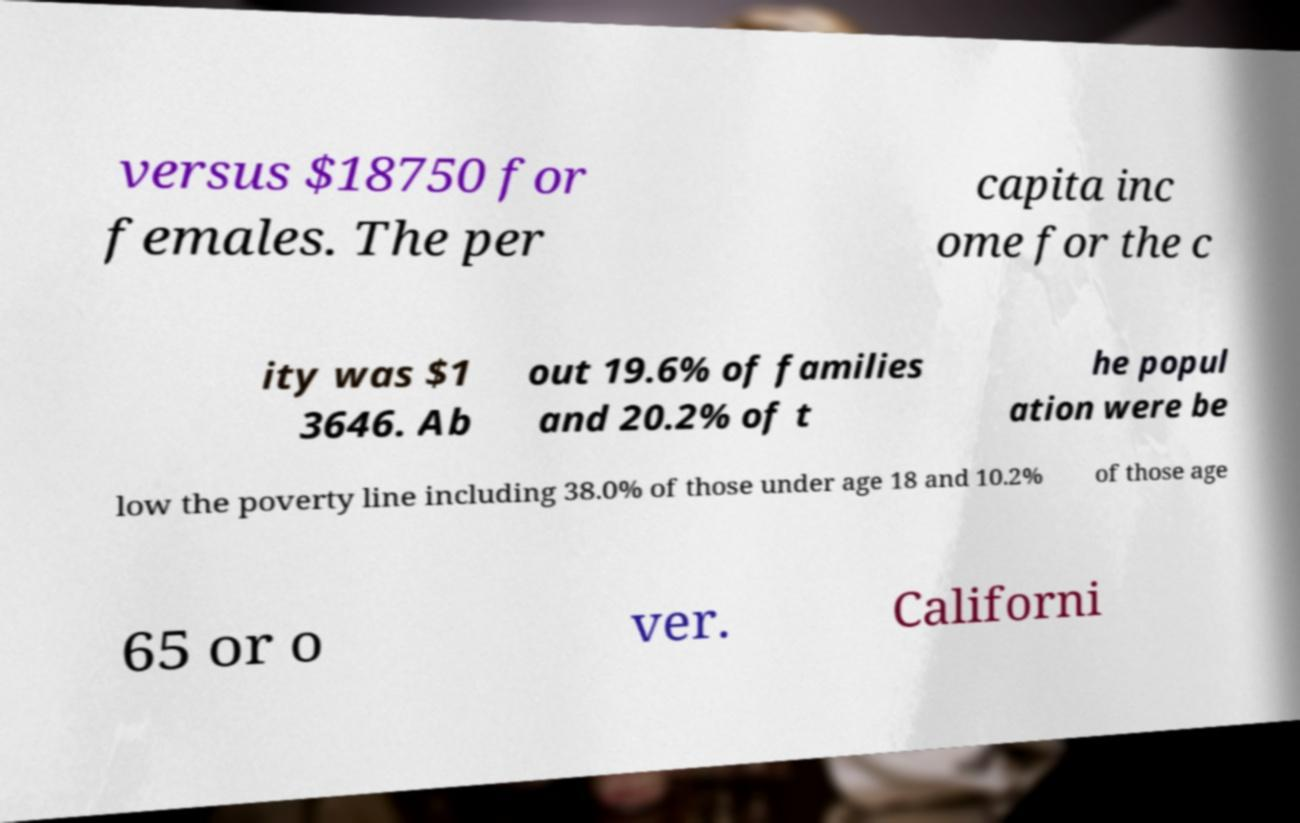I need the written content from this picture converted into text. Can you do that? versus $18750 for females. The per capita inc ome for the c ity was $1 3646. Ab out 19.6% of families and 20.2% of t he popul ation were be low the poverty line including 38.0% of those under age 18 and 10.2% of those age 65 or o ver. Californi 